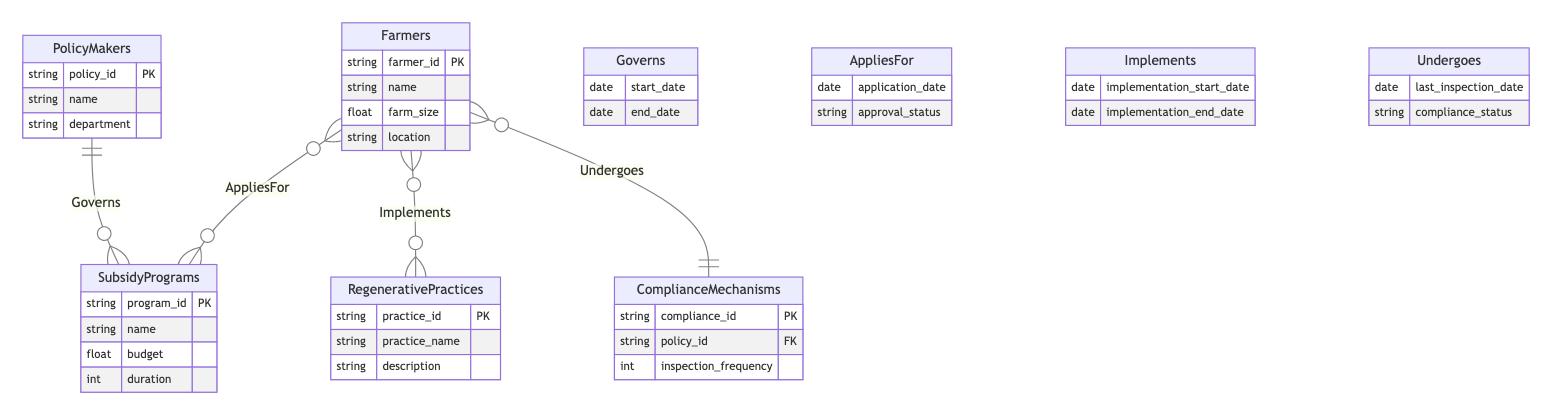What entities are involved in the diagram? The entities in the diagram are PolicyMakers, Farmers, RegenerativePractices, SubsidyPrograms, and ComplianceMechanisms. Each entity represents a key stakeholder or concept related to regenerative farming policy implementation.
Answer: PolicyMakers, Farmers, RegenerativePractices, SubsidyPrograms, ComplianceMechanisms How many relationships are depicted in the diagram? There are four relationships within the diagram: Governs, AppliesFor, Implements, and Undergoes. This indicates how various entities interact with each other in the context of regenerative farming policy.
Answer: 4 What attributes are associated with the Farmers entity? The Farmers entity has four attributes: farmer_id, name, farm_size, and location. These attributes provide essential information about each farmer involved in the policy implementation.
Answer: farmer_id, name, farm_size, location Which entity is governed by PolicyMakers? The relationship "Governs" indicates that PolicyMakers govern the SubsidyPrograms. This shows that the decisions made by PolicyMakers directly affect the SubsidyPrograms available to Farmers.
Answer: SubsidyPrograms What is the relationship between Farmers and RegenerativePractices? The relationship "Implements" illustrates that Farmers implement RegenerativePractices. This shows how Farmers are responsible for putting regenerative farming methods into action.
Answer: Implements What is the compliance mechanism that Farmers undergo? The relationship "Undergoes" shows that Farmers undergo ComplianceMechanisms. This indicates that Farmers are subjected to systems that ensure they comply with the farming policies established.
Answer: ComplianceMechanisms How many attributes does the SubsidyPrograms entity have? The SubsidyPrograms entity has four attributes: program_id, name, budget, and duration. These attributes help to define the various subsidy programs available to promote regenerative farming.
Answer: 4 What is required for Farmers to apply for SubsidyPrograms? The relationship "AppliesFor" indicates that Farmers must submit an application. This relationship details that Farmers seek support from SubsidyPrograms through an application process.
Answer: application Which entity is linked to compliance through inspection frequency? The ComplianceMechanisms entity links to compliance through the attribute inspection_frequency. This attribute indicates how often inspections are carried out to ensure adherence to farming policies.
Answer: ComplianceMechanisms 